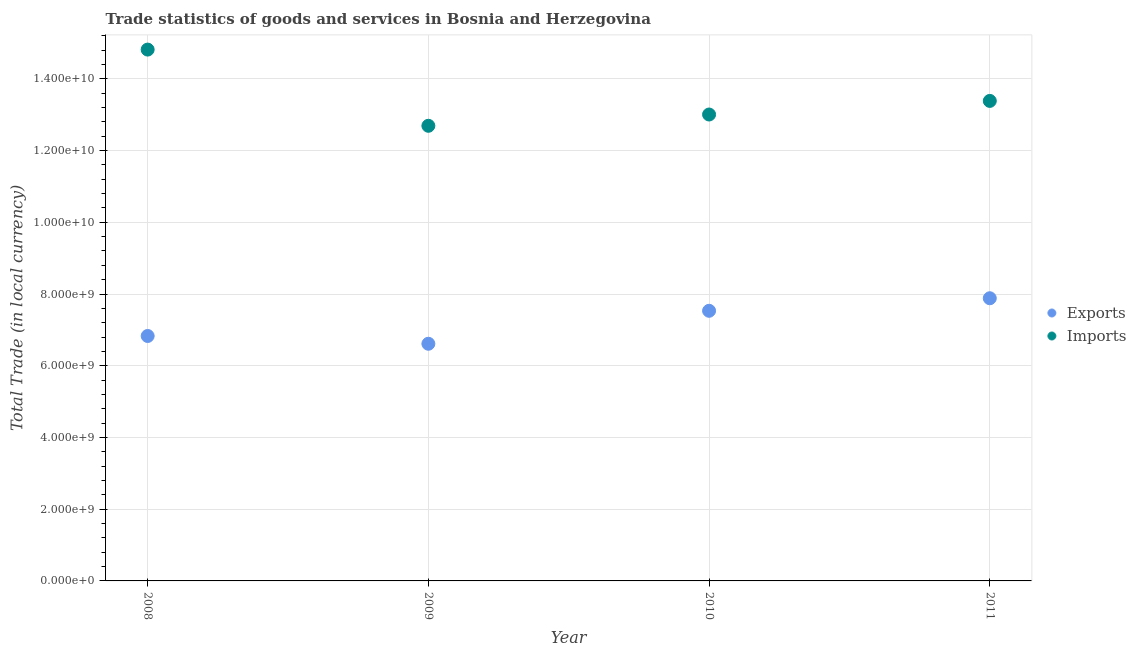How many different coloured dotlines are there?
Provide a succinct answer. 2. What is the export of goods and services in 2010?
Keep it short and to the point. 7.53e+09. Across all years, what is the maximum imports of goods and services?
Provide a short and direct response. 1.48e+1. Across all years, what is the minimum imports of goods and services?
Give a very brief answer. 1.27e+1. In which year was the imports of goods and services maximum?
Offer a terse response. 2008. What is the total imports of goods and services in the graph?
Keep it short and to the point. 5.39e+1. What is the difference between the imports of goods and services in 2010 and that in 2011?
Give a very brief answer. -3.79e+08. What is the difference between the imports of goods and services in 2010 and the export of goods and services in 2009?
Your response must be concise. 6.39e+09. What is the average imports of goods and services per year?
Ensure brevity in your answer.  1.35e+1. In the year 2009, what is the difference between the imports of goods and services and export of goods and services?
Your answer should be compact. 6.08e+09. What is the ratio of the imports of goods and services in 2008 to that in 2010?
Provide a short and direct response. 1.14. What is the difference between the highest and the second highest export of goods and services?
Offer a very short reply. 3.50e+08. What is the difference between the highest and the lowest imports of goods and services?
Provide a short and direct response. 2.13e+09. In how many years, is the export of goods and services greater than the average export of goods and services taken over all years?
Offer a very short reply. 2. Is the sum of the export of goods and services in 2008 and 2011 greater than the maximum imports of goods and services across all years?
Provide a short and direct response. No. Does the imports of goods and services monotonically increase over the years?
Keep it short and to the point. No. Is the imports of goods and services strictly less than the export of goods and services over the years?
Offer a very short reply. No. What is the difference between two consecutive major ticks on the Y-axis?
Give a very brief answer. 2.00e+09. Does the graph contain any zero values?
Give a very brief answer. No. Does the graph contain grids?
Your answer should be very brief. Yes. Where does the legend appear in the graph?
Offer a terse response. Center right. What is the title of the graph?
Ensure brevity in your answer.  Trade statistics of goods and services in Bosnia and Herzegovina. What is the label or title of the X-axis?
Ensure brevity in your answer.  Year. What is the label or title of the Y-axis?
Your response must be concise. Total Trade (in local currency). What is the Total Trade (in local currency) of Exports in 2008?
Your response must be concise. 6.83e+09. What is the Total Trade (in local currency) of Imports in 2008?
Keep it short and to the point. 1.48e+1. What is the Total Trade (in local currency) of Exports in 2009?
Ensure brevity in your answer.  6.61e+09. What is the Total Trade (in local currency) in Imports in 2009?
Provide a short and direct response. 1.27e+1. What is the Total Trade (in local currency) of Exports in 2010?
Offer a very short reply. 7.53e+09. What is the Total Trade (in local currency) in Imports in 2010?
Offer a terse response. 1.30e+1. What is the Total Trade (in local currency) in Exports in 2011?
Make the answer very short. 7.88e+09. What is the Total Trade (in local currency) in Imports in 2011?
Make the answer very short. 1.34e+1. Across all years, what is the maximum Total Trade (in local currency) of Exports?
Offer a terse response. 7.88e+09. Across all years, what is the maximum Total Trade (in local currency) of Imports?
Give a very brief answer. 1.48e+1. Across all years, what is the minimum Total Trade (in local currency) of Exports?
Ensure brevity in your answer.  6.61e+09. Across all years, what is the minimum Total Trade (in local currency) in Imports?
Give a very brief answer. 1.27e+1. What is the total Total Trade (in local currency) of Exports in the graph?
Your response must be concise. 2.89e+1. What is the total Total Trade (in local currency) in Imports in the graph?
Offer a very short reply. 5.39e+1. What is the difference between the Total Trade (in local currency) in Exports in 2008 and that in 2009?
Make the answer very short. 2.17e+08. What is the difference between the Total Trade (in local currency) of Imports in 2008 and that in 2009?
Your answer should be compact. 2.13e+09. What is the difference between the Total Trade (in local currency) in Exports in 2008 and that in 2010?
Keep it short and to the point. -7.02e+08. What is the difference between the Total Trade (in local currency) of Imports in 2008 and that in 2010?
Make the answer very short. 1.81e+09. What is the difference between the Total Trade (in local currency) of Exports in 2008 and that in 2011?
Make the answer very short. -1.05e+09. What is the difference between the Total Trade (in local currency) in Imports in 2008 and that in 2011?
Your response must be concise. 1.43e+09. What is the difference between the Total Trade (in local currency) of Exports in 2009 and that in 2010?
Ensure brevity in your answer.  -9.19e+08. What is the difference between the Total Trade (in local currency) of Imports in 2009 and that in 2010?
Provide a short and direct response. -3.15e+08. What is the difference between the Total Trade (in local currency) of Exports in 2009 and that in 2011?
Ensure brevity in your answer.  -1.27e+09. What is the difference between the Total Trade (in local currency) in Imports in 2009 and that in 2011?
Your answer should be very brief. -6.94e+08. What is the difference between the Total Trade (in local currency) of Exports in 2010 and that in 2011?
Provide a succinct answer. -3.50e+08. What is the difference between the Total Trade (in local currency) of Imports in 2010 and that in 2011?
Give a very brief answer. -3.79e+08. What is the difference between the Total Trade (in local currency) of Exports in 2008 and the Total Trade (in local currency) of Imports in 2009?
Your response must be concise. -5.86e+09. What is the difference between the Total Trade (in local currency) in Exports in 2008 and the Total Trade (in local currency) in Imports in 2010?
Keep it short and to the point. -6.18e+09. What is the difference between the Total Trade (in local currency) of Exports in 2008 and the Total Trade (in local currency) of Imports in 2011?
Provide a short and direct response. -6.55e+09. What is the difference between the Total Trade (in local currency) in Exports in 2009 and the Total Trade (in local currency) in Imports in 2010?
Make the answer very short. -6.39e+09. What is the difference between the Total Trade (in local currency) in Exports in 2009 and the Total Trade (in local currency) in Imports in 2011?
Your answer should be compact. -6.77e+09. What is the difference between the Total Trade (in local currency) in Exports in 2010 and the Total Trade (in local currency) in Imports in 2011?
Offer a very short reply. -5.85e+09. What is the average Total Trade (in local currency) of Exports per year?
Offer a very short reply. 7.21e+09. What is the average Total Trade (in local currency) of Imports per year?
Your answer should be compact. 1.35e+1. In the year 2008, what is the difference between the Total Trade (in local currency) in Exports and Total Trade (in local currency) in Imports?
Your answer should be compact. -7.99e+09. In the year 2009, what is the difference between the Total Trade (in local currency) of Exports and Total Trade (in local currency) of Imports?
Keep it short and to the point. -6.08e+09. In the year 2010, what is the difference between the Total Trade (in local currency) in Exports and Total Trade (in local currency) in Imports?
Keep it short and to the point. -5.47e+09. In the year 2011, what is the difference between the Total Trade (in local currency) in Exports and Total Trade (in local currency) in Imports?
Offer a terse response. -5.50e+09. What is the ratio of the Total Trade (in local currency) of Exports in 2008 to that in 2009?
Give a very brief answer. 1.03. What is the ratio of the Total Trade (in local currency) of Imports in 2008 to that in 2009?
Your answer should be very brief. 1.17. What is the ratio of the Total Trade (in local currency) of Exports in 2008 to that in 2010?
Offer a terse response. 0.91. What is the ratio of the Total Trade (in local currency) of Imports in 2008 to that in 2010?
Ensure brevity in your answer.  1.14. What is the ratio of the Total Trade (in local currency) of Exports in 2008 to that in 2011?
Your answer should be very brief. 0.87. What is the ratio of the Total Trade (in local currency) in Imports in 2008 to that in 2011?
Provide a succinct answer. 1.11. What is the ratio of the Total Trade (in local currency) in Exports in 2009 to that in 2010?
Your answer should be very brief. 0.88. What is the ratio of the Total Trade (in local currency) in Imports in 2009 to that in 2010?
Offer a very short reply. 0.98. What is the ratio of the Total Trade (in local currency) of Exports in 2009 to that in 2011?
Provide a short and direct response. 0.84. What is the ratio of the Total Trade (in local currency) in Imports in 2009 to that in 2011?
Offer a terse response. 0.95. What is the ratio of the Total Trade (in local currency) of Exports in 2010 to that in 2011?
Give a very brief answer. 0.96. What is the ratio of the Total Trade (in local currency) in Imports in 2010 to that in 2011?
Provide a succinct answer. 0.97. What is the difference between the highest and the second highest Total Trade (in local currency) in Exports?
Provide a short and direct response. 3.50e+08. What is the difference between the highest and the second highest Total Trade (in local currency) in Imports?
Make the answer very short. 1.43e+09. What is the difference between the highest and the lowest Total Trade (in local currency) of Exports?
Provide a succinct answer. 1.27e+09. What is the difference between the highest and the lowest Total Trade (in local currency) in Imports?
Your response must be concise. 2.13e+09. 